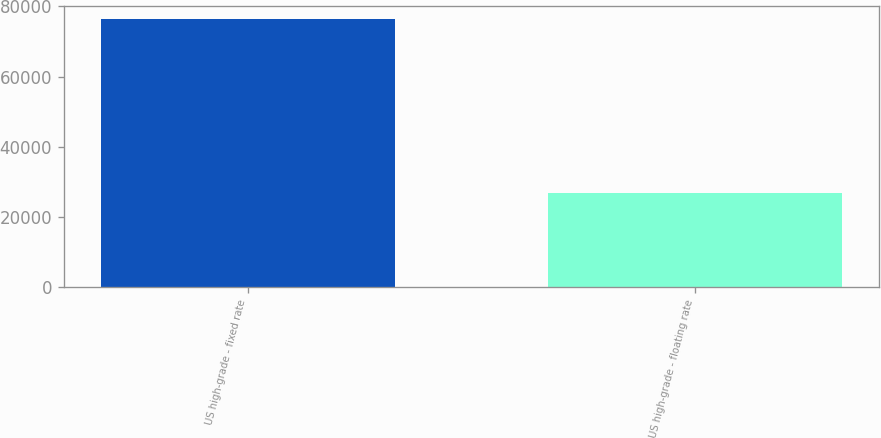<chart> <loc_0><loc_0><loc_500><loc_500><bar_chart><fcel>US high-grade - fixed rate<fcel>US high-grade - floating rate<nl><fcel>76324<fcel>26815<nl></chart> 